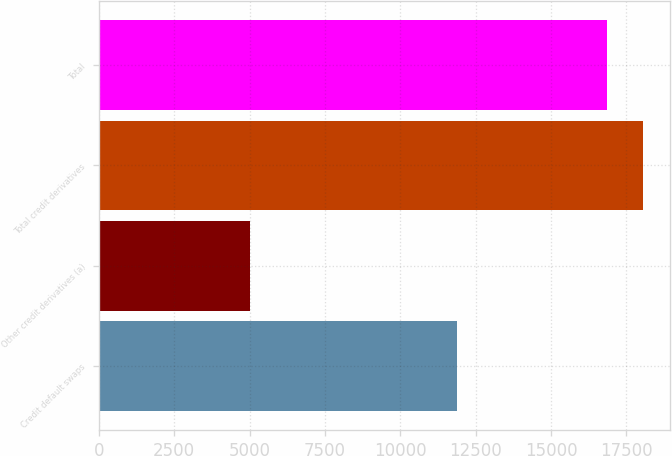Convert chart. <chart><loc_0><loc_0><loc_500><loc_500><bar_chart><fcel>Credit default swaps<fcel>Other credit derivatives (a)<fcel>Total credit derivatives<fcel>Total<nl><fcel>11874<fcel>5001<fcel>18044.4<fcel>16857<nl></chart> 